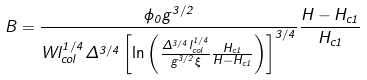Convert formula to latex. <formula><loc_0><loc_0><loc_500><loc_500>B = \frac { \phi _ { 0 } g ^ { 3 / 2 } } { W l _ { c o l } ^ { 1 / 4 } \Delta ^ { 3 / 4 } \left [ \ln \left ( \frac { \Delta ^ { 3 / 4 } l _ { c o l } ^ { 1 / 4 } } { g ^ { 3 / 2 } \xi } \frac { H _ { c 1 } } { H - H _ { c 1 } } \right ) \right ] ^ { 3 / 4 } } \frac { H - H _ { c 1 } } { H _ { c 1 } }</formula> 